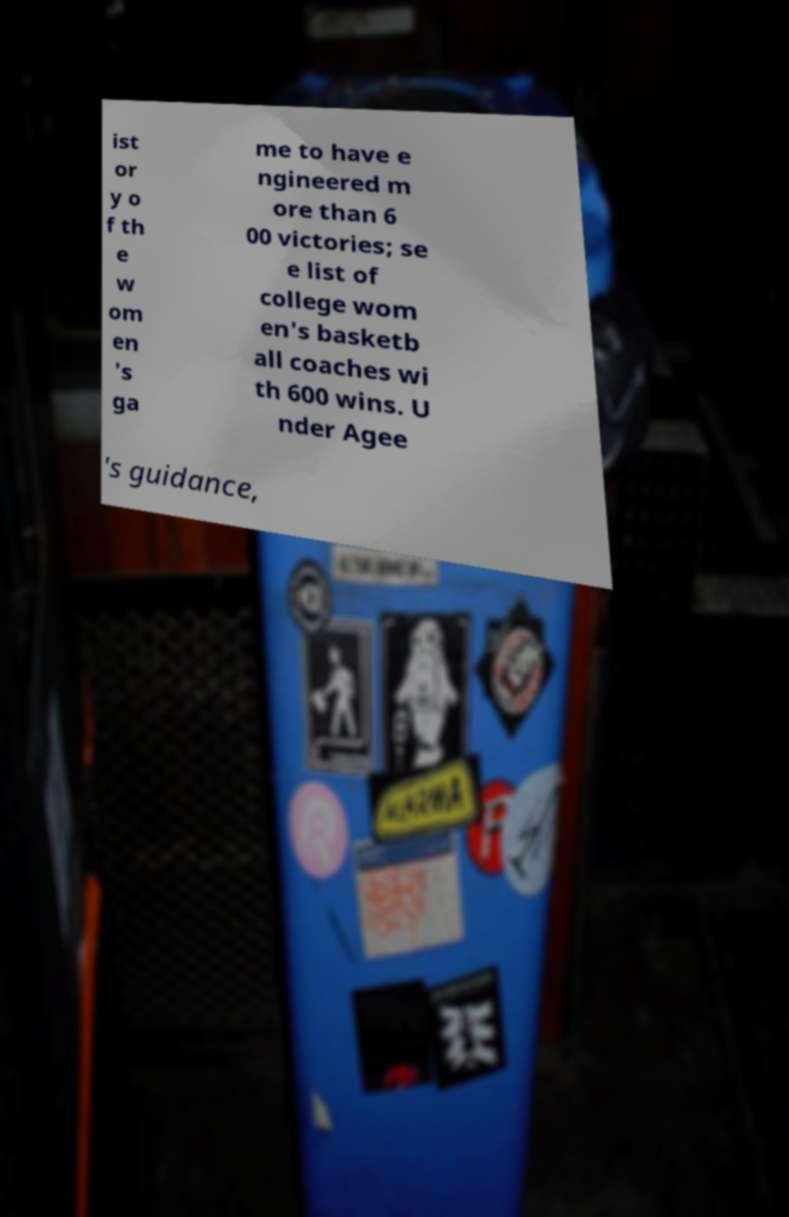I need the written content from this picture converted into text. Can you do that? ist or y o f th e w om en 's ga me to have e ngineered m ore than 6 00 victories; se e list of college wom en's basketb all coaches wi th 600 wins. U nder Agee 's guidance, 